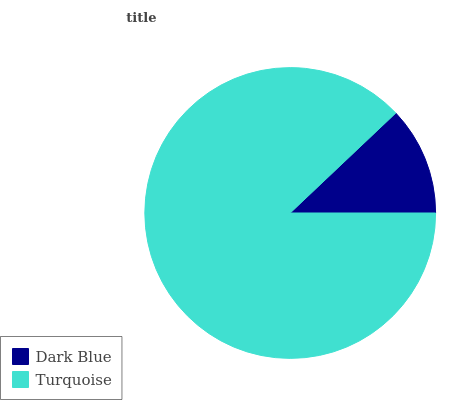Is Dark Blue the minimum?
Answer yes or no. Yes. Is Turquoise the maximum?
Answer yes or no. Yes. Is Turquoise the minimum?
Answer yes or no. No. Is Turquoise greater than Dark Blue?
Answer yes or no. Yes. Is Dark Blue less than Turquoise?
Answer yes or no. Yes. Is Dark Blue greater than Turquoise?
Answer yes or no. No. Is Turquoise less than Dark Blue?
Answer yes or no. No. Is Turquoise the high median?
Answer yes or no. Yes. Is Dark Blue the low median?
Answer yes or no. Yes. Is Dark Blue the high median?
Answer yes or no. No. Is Turquoise the low median?
Answer yes or no. No. 